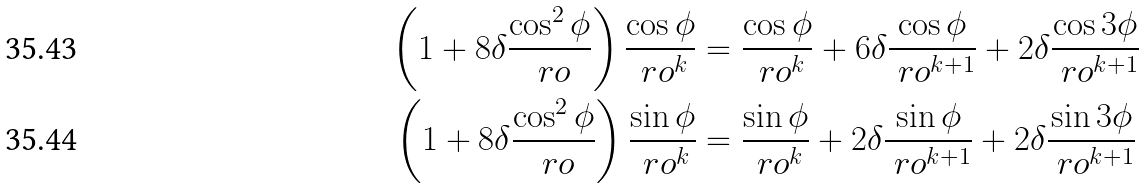<formula> <loc_0><loc_0><loc_500><loc_500>\left ( 1 + 8 \delta \frac { \cos ^ { 2 } \phi } { \ r o } \right ) \frac { \cos { \phi } } { \ r o ^ { k } } & = \frac { \cos \phi } { \ r o ^ { k } } + 6 \delta \frac { \cos \phi } { \ r o ^ { k + 1 } } + 2 \delta \frac { \cos 3 \phi } { \ r o ^ { k + 1 } } \\ \left ( 1 + 8 \delta \frac { \cos ^ { 2 } \phi } { \ r o } \right ) \frac { \sin { \phi } } { \ r o ^ { k } } & = \frac { \sin \phi } { \ r o ^ { k } } + 2 \delta \frac { \sin \phi } { \ r o ^ { k + 1 } } + 2 \delta \frac { \sin 3 \phi } { \ r o ^ { k + 1 } }</formula> 